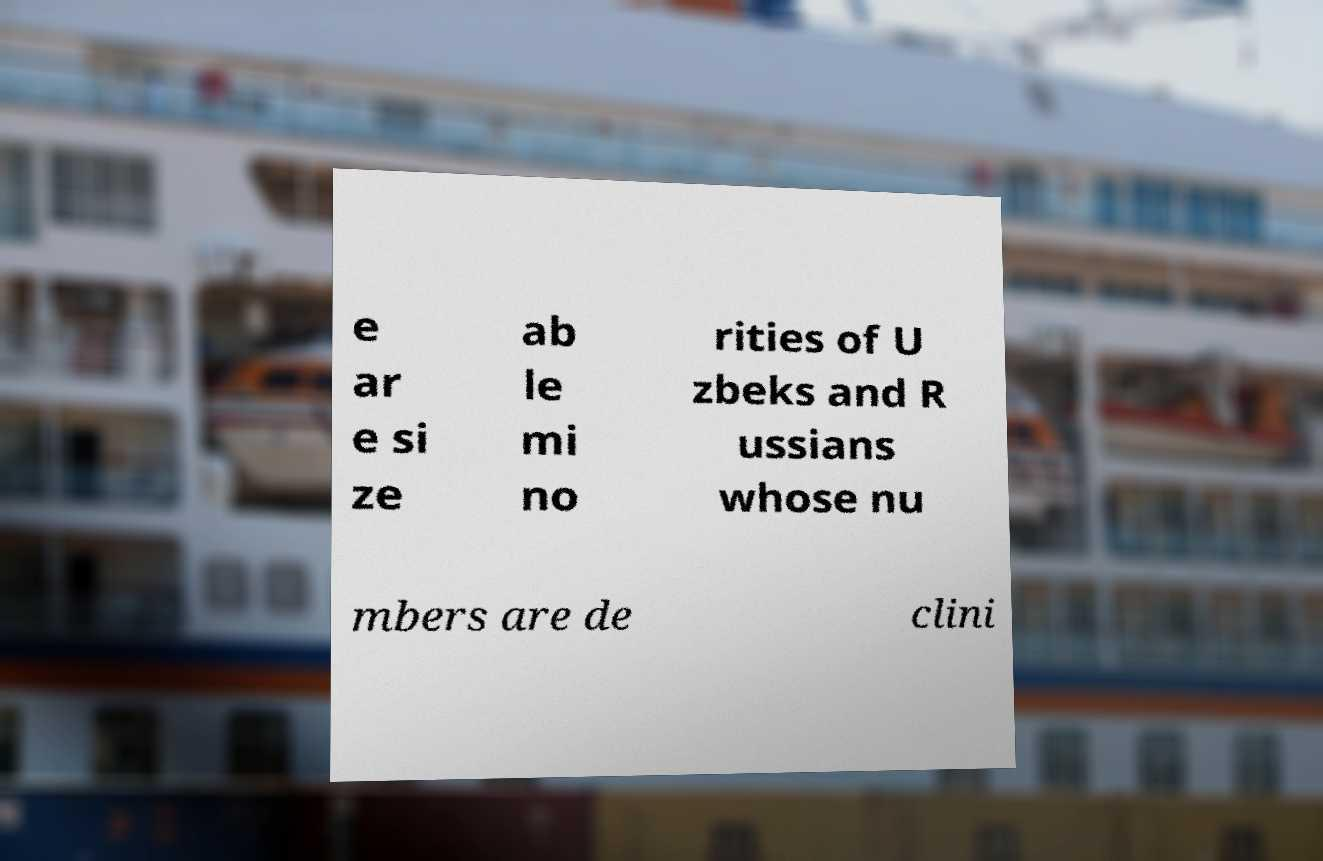Please identify and transcribe the text found in this image. e ar e si ze ab le mi no rities of U zbeks and R ussians whose nu mbers are de clini 